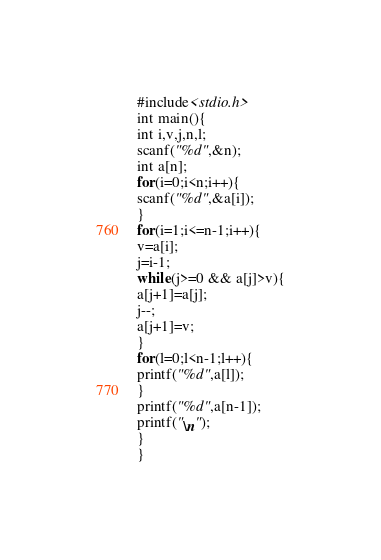<code> <loc_0><loc_0><loc_500><loc_500><_C_>#include<stdio.h>
int main(){
int i,v,j,n,l;
scanf("%d",&n);
int a[n];
for(i=0;i<n;i++){
scanf("%d",&a[i]);
}
for(i=1;i<=n-1;i++){
v=a[i];
j=i-1;
while(j>=0 && a[j]>v){
a[j+1]=a[j];
j--;
a[j+1]=v;
}
for(l=0;l<n-1;l++){
printf("%d",a[l]);
}
printf("%d",a[n-1]);
printf("\n");
}
}

</code> 